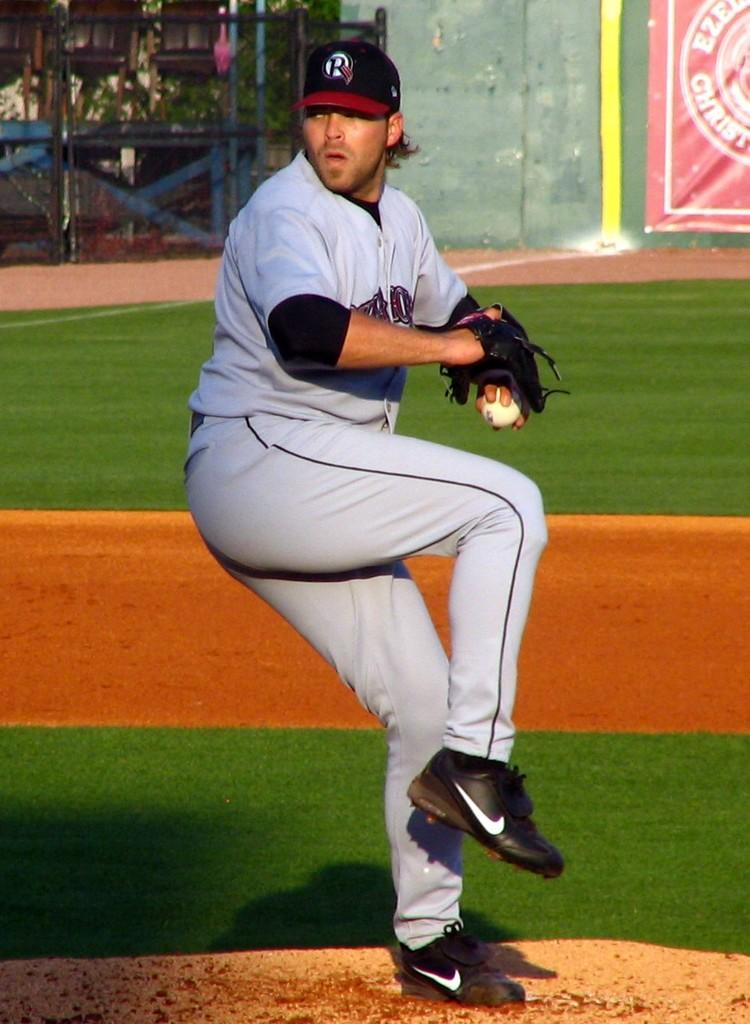<image>
Relay a brief, clear account of the picture shown. The pitcher on the mound has a Houston hat and uniform on. 